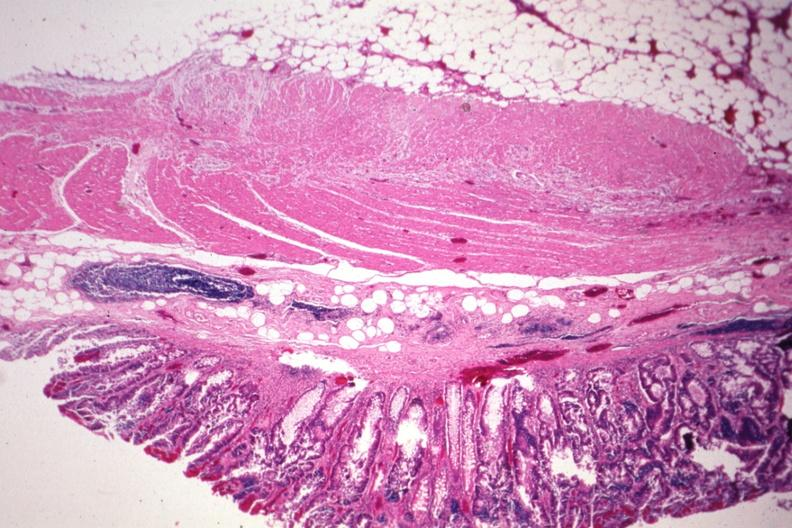does this image show nice photo with obvious tumor in mucosa?
Answer the question using a single word or phrase. Yes 